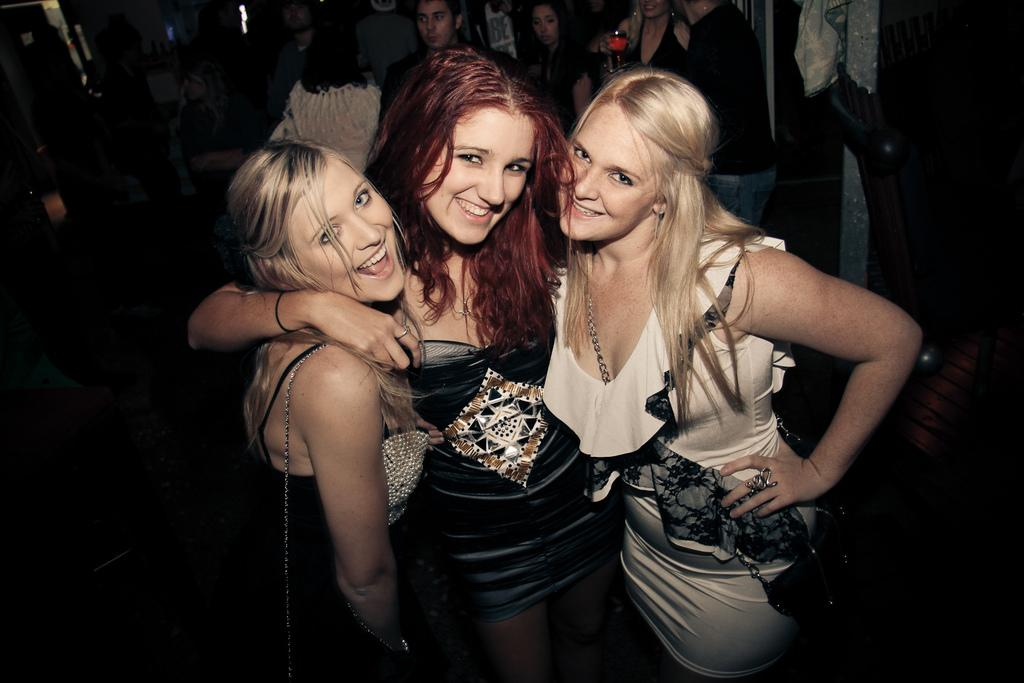How many women are in the image? There are three women in the image. What are the women doing in the image? The women are standing close to each other. Can you describe the background of the image? There are people visible in the background of the image. What type of mint can be smelled in the image? There is no mint present in the image, and therefore no scent can be detected. 